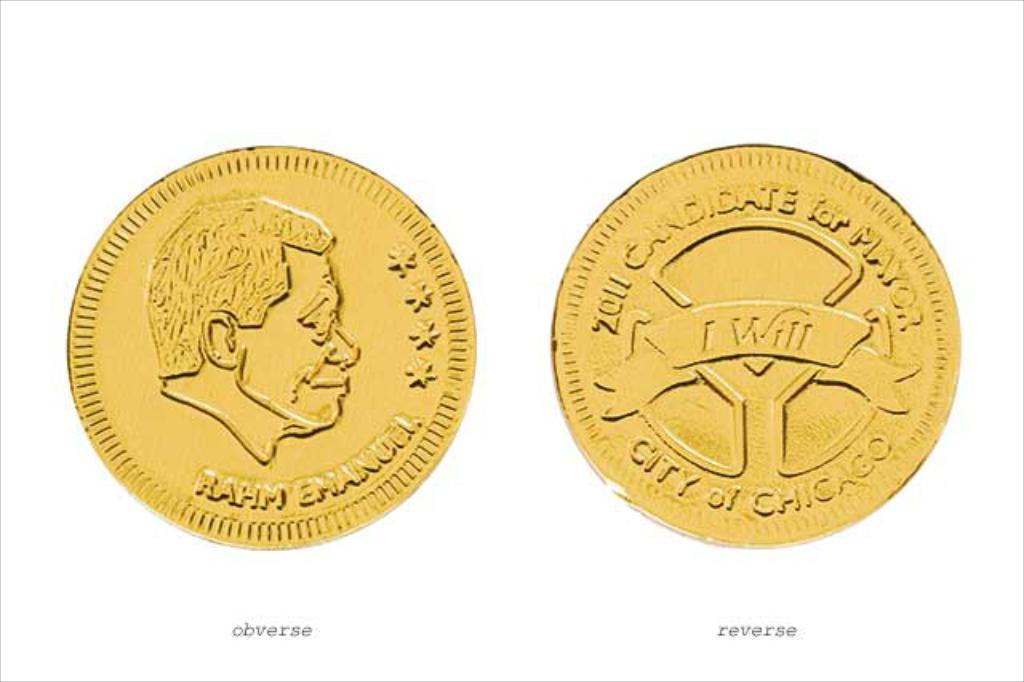<image>
Share a concise interpretation of the image provided. front (obverse) and back (reverse) of rahm emanuel gold coin from city of chicago 